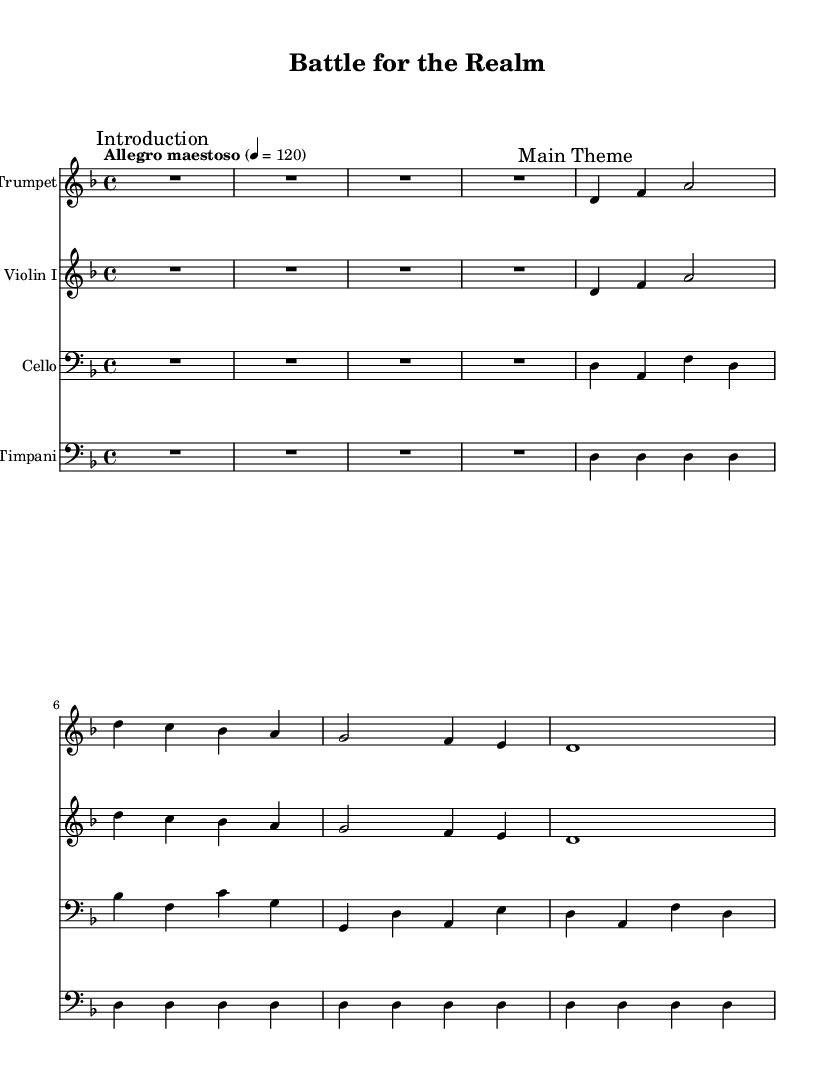What is the key signature of this music? The key signature is indicated at the beginning of the score. In this case, it shows two flats, which corresponds to the key of D minor.
Answer: D minor What is the time signature of this music? The time signature is found at the beginning of the score, indicating how many beats are in each measure. Here, it shows a 4/4 time signature, which means there are 4 beats per measure.
Answer: 4/4 What is the tempo marking of this music? The tempo is indicated above the staff. In this piece, it is marked "Allegro maestoso," which indicates a fast and majestic tempo. The exact beats per minute is also given as 120.
Answer: Allegro maestoso Which instrument plays the introduction? The introduction is marked specifically in the score for the trumpet, as the first instrument listed and denoted with "Introduction" as a mark.
Answer: Trumpet What is the main theme presented in the music? The main theme is indicated by the mark "Main Theme" appearing above the notes. The notes played by both the trumpet and violin represent this theme, which starts with D, F, and A.
Answer: D, F, A How many measures are in the cello part before the first statement of the main theme? The cello part has a couple of measures rest initially, marked by R1*4. Counting the number of full measures until the notes begin helps determine this; there is one measure of rest before the theme begins.
Answer: 1 What is the rhythmic pattern predominantly used in the timpani part? The timpani part features a repetitive pattern throughout its section, marked by the same rhythmic figure played in each measure, specifically quarter notes that maintain a steady pulse.
Answer: Quarter notes 